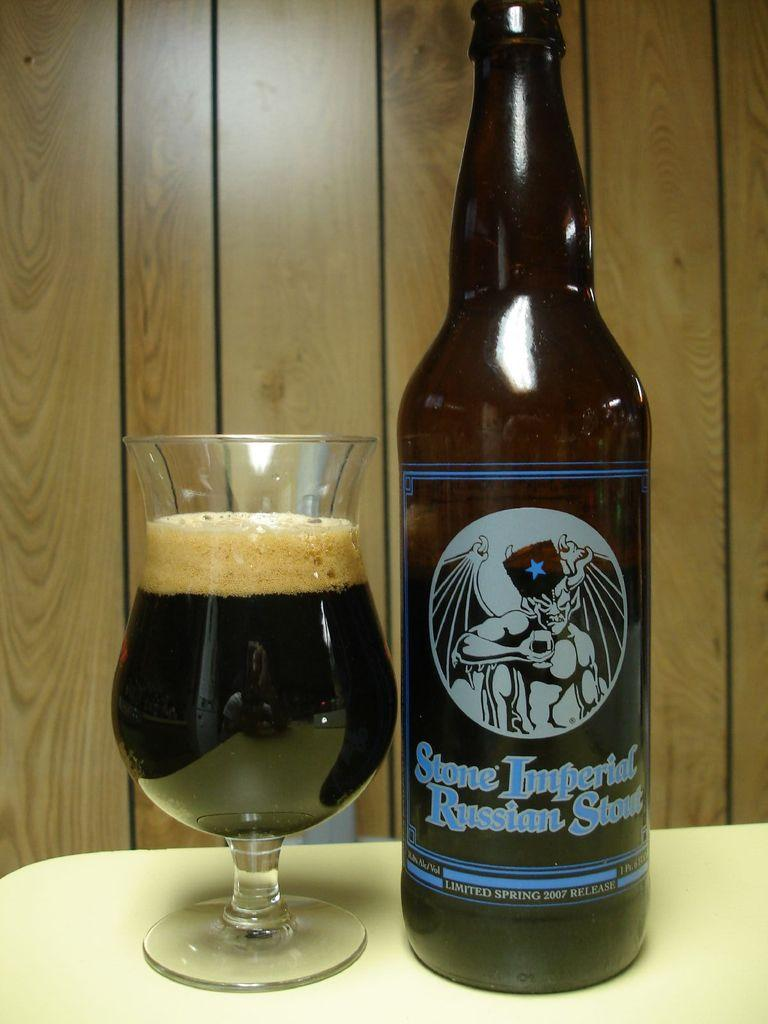<image>
Present a compact description of the photo's key features. A glass full of Stone Imperial Russian Stout sits next to its bottle. 